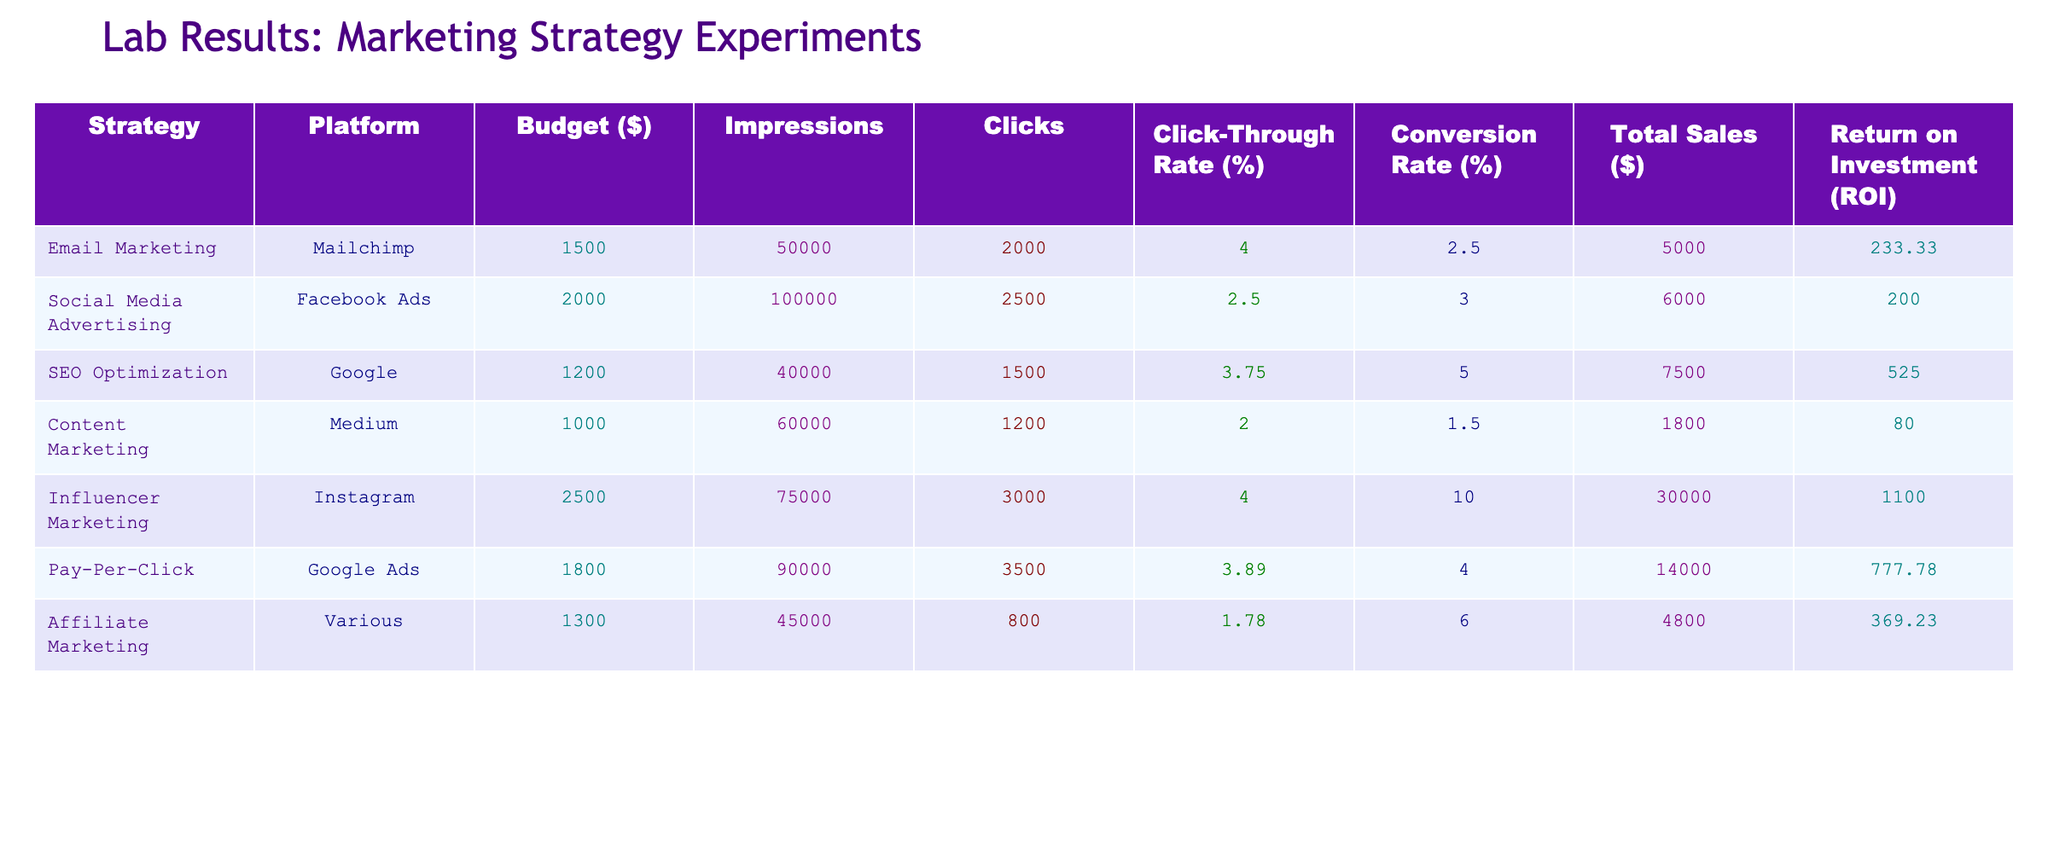What is the total budget spent on all marketing strategies combined? To find the total budget, we sum the budget values for each strategy: 1500 + 2000 + 1200 + 1000 + 2500 + 1800 + 1300 = 11300.
Answer: 11300 Which marketing strategy generated the highest total sales? By comparing the Total Sales column, Influencer Marketing has the highest value at 30000, while others are lower (SEO Optimization has 7500, for example).
Answer: Influencer Marketing What is the average click-through rate across all strategies? To calculate the average Click-Through Rate, we add the values (4.00 + 2.50 + 3.75 + 2.00 + 4.00 + 3.89 + 1.78) = 22.92 and divide by 7 (the number of strategies): 22.92 / 7 ≈ 3.28.
Answer: 3.28 Did Affiliate Marketing have a higher conversion rate than Content Marketing? By comparing the Conversion Rates, Affiliate Marketing is 6.00, which is higher than Content Marketing's 1.50.
Answer: Yes What is the ROI for Pay-Per-Click and how does it compare to the average ROI of all strategies? The ROI for Pay-Per-Click is 777.78. To find the average ROI, sum all ROI values (233.33 + 200.00 + 525.00 + 80.00 + 1100 + 777.78 + 369.23) = 3285.34, then divide by 7: 3285.34 / 7 ≈ 468.05. Since 777.78 > 468.05, Pay-Per-Click's ROI is higher than average.
Answer: Higher than average Which platform had the least amount spent on marketing? By examining the Budget column, Content Marketing had the least amount spent at 1000, while others are higher: Email Marketing is 1500, Social Media Advertising is 2000, etc.
Answer: Medium 